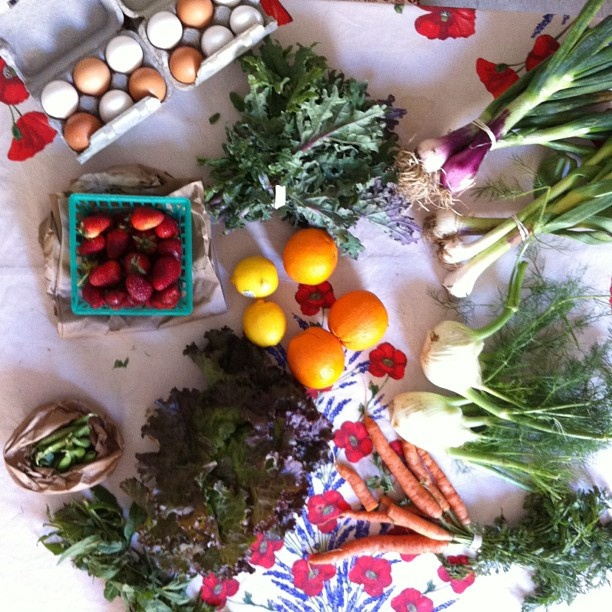Describe the objects in this image and their specific colors. I can see carrot in white, salmon, and brown tones, orange in white, red, orange, gold, and khaki tones, orange in white, red, orange, gold, and brown tones, orange in white, red, orange, gold, and brown tones, and orange in white, gold, olive, orange, and yellow tones in this image. 